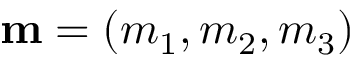<formula> <loc_0><loc_0><loc_500><loc_500>{ m } = ( m _ { 1 } , m _ { 2 } , m _ { 3 } )</formula> 